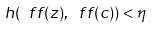Convert formula to latex. <formula><loc_0><loc_0><loc_500><loc_500>h ( \ f f ( z ) , \ f f ( c ) ) < \eta</formula> 